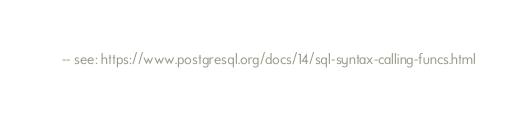<code> <loc_0><loc_0><loc_500><loc_500><_SQL_>-- see: https://www.postgresql.org/docs/14/sql-syntax-calling-funcs.html
</code> 